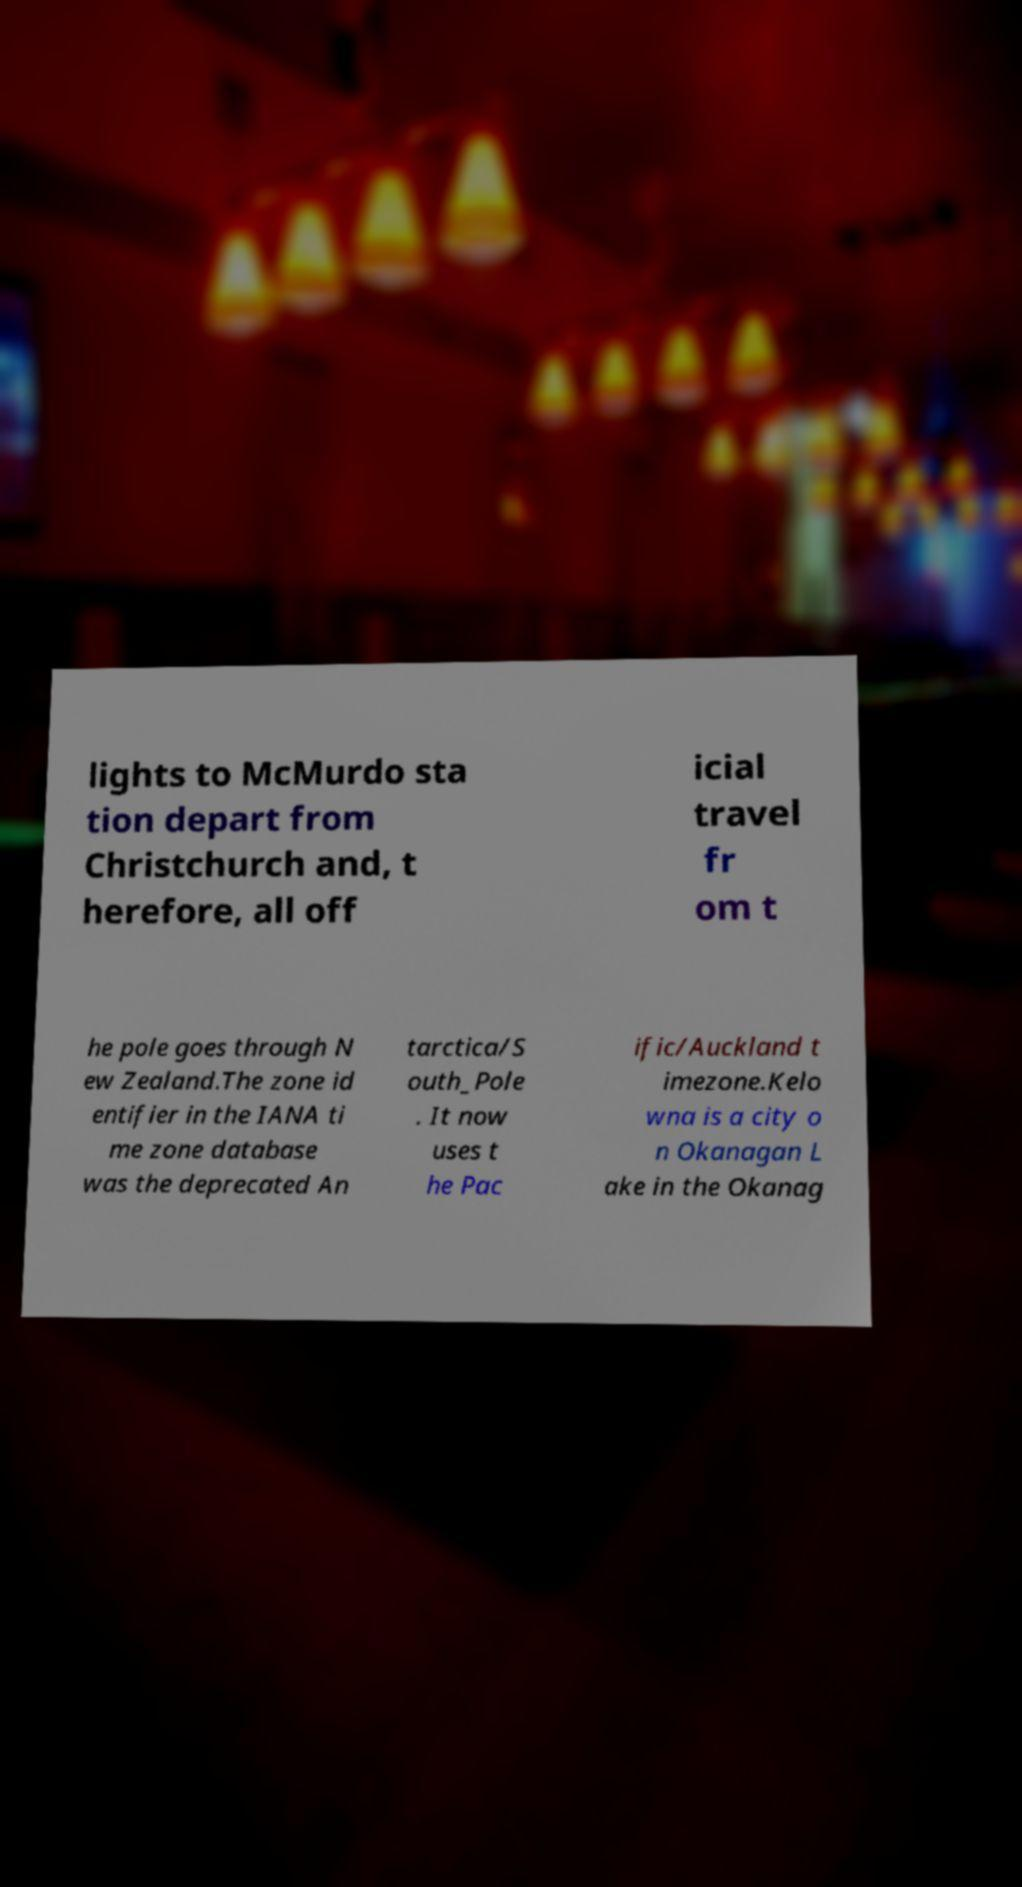For documentation purposes, I need the text within this image transcribed. Could you provide that? lights to McMurdo sta tion depart from Christchurch and, t herefore, all off icial travel fr om t he pole goes through N ew Zealand.The zone id entifier in the IANA ti me zone database was the deprecated An tarctica/S outh_Pole . It now uses t he Pac ific/Auckland t imezone.Kelo wna is a city o n Okanagan L ake in the Okanag 